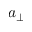Convert formula to latex. <formula><loc_0><loc_0><loc_500><loc_500>a _ { \perp }</formula> 